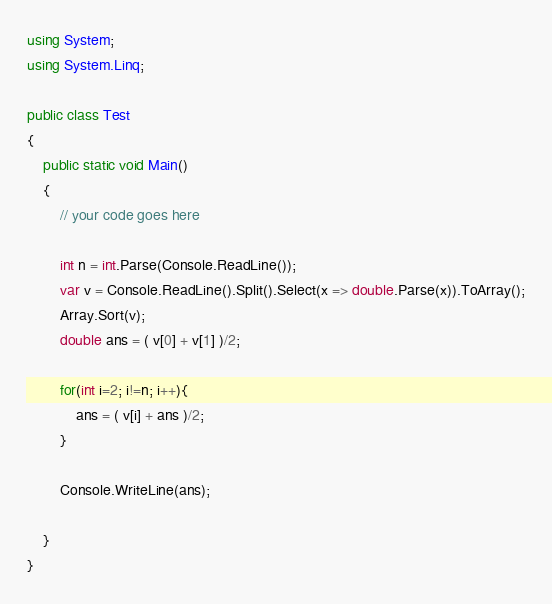<code> <loc_0><loc_0><loc_500><loc_500><_C#_>using System;
using System.Linq;

public class Test
{
	public static void Main()
	{
		// your code goes here
		
		int n = int.Parse(Console.ReadLine());
		var v = Console.ReadLine().Split().Select(x => double.Parse(x)).ToArray();
		Array.Sort(v);
		double ans = ( v[0] + v[1] )/2;
		
		for(int i=2; i!=n; i++){
			ans = ( v[i] + ans )/2;
		}
		
		Console.WriteLine(ans);
		
	}
}</code> 